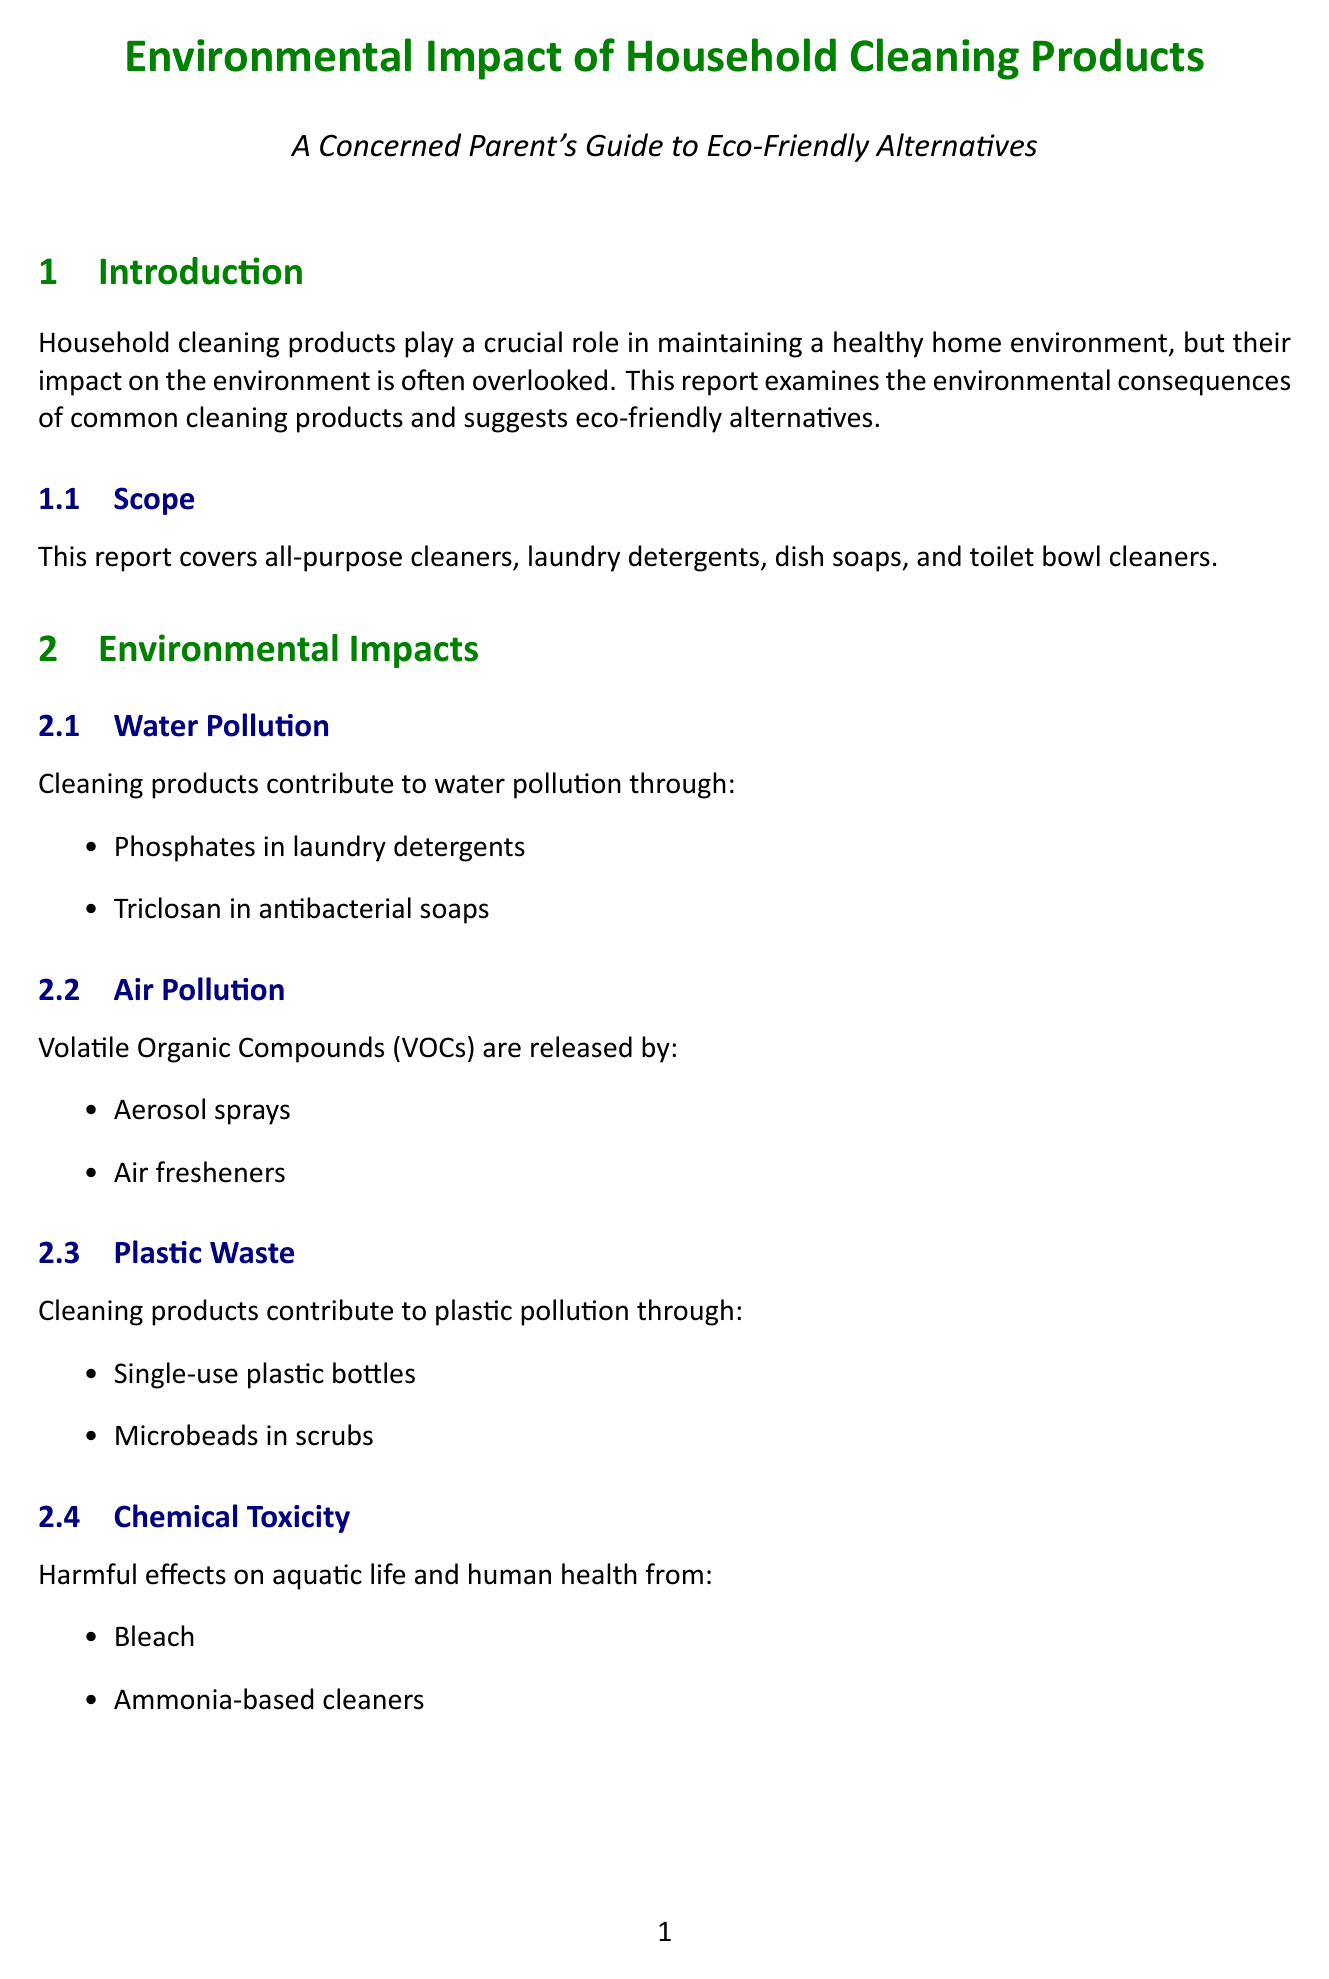What are the common household products analyzed in the report? The report analyzes all-purpose cleaners, laundry detergents, dish soaps, and toilet bowl cleaners.
Answer: All-purpose cleaners, laundry detergents, dish soaps, toilet bowl cleaners What is one example of water pollution caused by cleaning products? The document mentions specific examples of how cleaning products contribute to water pollution.
Answer: Triclosan in antibacterial soaps What type of cleaner is suggested as an eco-friendly alternative to all-purpose cleaners? The eco-friendly alternatives section provides specific replacements for common cleaning products.
Answer: Homemade vinegar and water solution What harmful chemical is associated with toilet bowl cleaners? The document outlines the environmental concerns tied to toilet bowl cleaners including specific harmful substances.
Answer: Chlorine compounds How can parents involve their children in cleaning activities? The tips section for parents offers suggestions on how to engage children in eco-friendly cleaning practices.
Answer: Involve kids in making homemade cleaning solutions What is one benefit of using Blueland Dish Soap? The benefits of eco-friendly alternatives are highlighted in the report, describing specific advantages.
Answer: Plastic-free What is the main purpose of the report? The introduction explains the primary focus of the document regarding household cleaning products and their impact.
Answer: To examine environmental impact and suggest eco-friendly alternatives How many tips for parents are listed in the report? The tips section provides a countable list that can be easily referenced.
Answer: Five What organization is suggested for additional resources linked to cleaning products? The additional resources section includes organizations that provide information on cleaning products.
Answer: Environmental Working Group (EWG) 